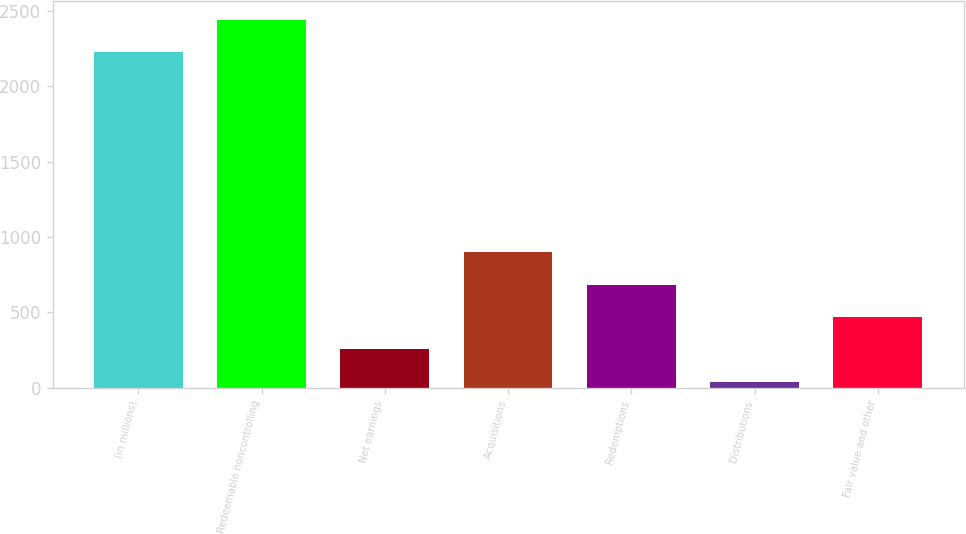Convert chart. <chart><loc_0><loc_0><loc_500><loc_500><bar_chart><fcel>(in millions)<fcel>Redeemable noncontrolling<fcel>Net earnings<fcel>Acquisitions<fcel>Redemptions<fcel>Distributions<fcel>Fair value and other<nl><fcel>2227.1<fcel>2442.2<fcel>253.1<fcel>898.4<fcel>683.3<fcel>38<fcel>468.2<nl></chart> 